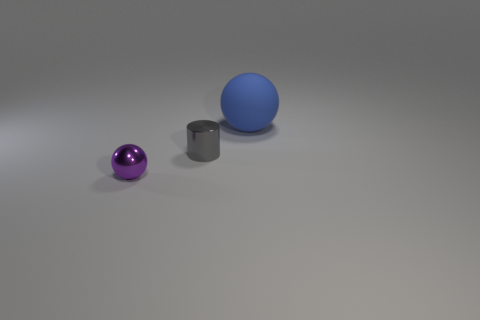Add 2 yellow shiny cylinders. How many objects exist? 5 Subtract all spheres. How many objects are left? 1 Add 1 small shiny cylinders. How many small shiny cylinders are left? 2 Add 2 matte balls. How many matte balls exist? 3 Subtract 1 purple balls. How many objects are left? 2 Subtract all small gray metallic cylinders. Subtract all small gray things. How many objects are left? 1 